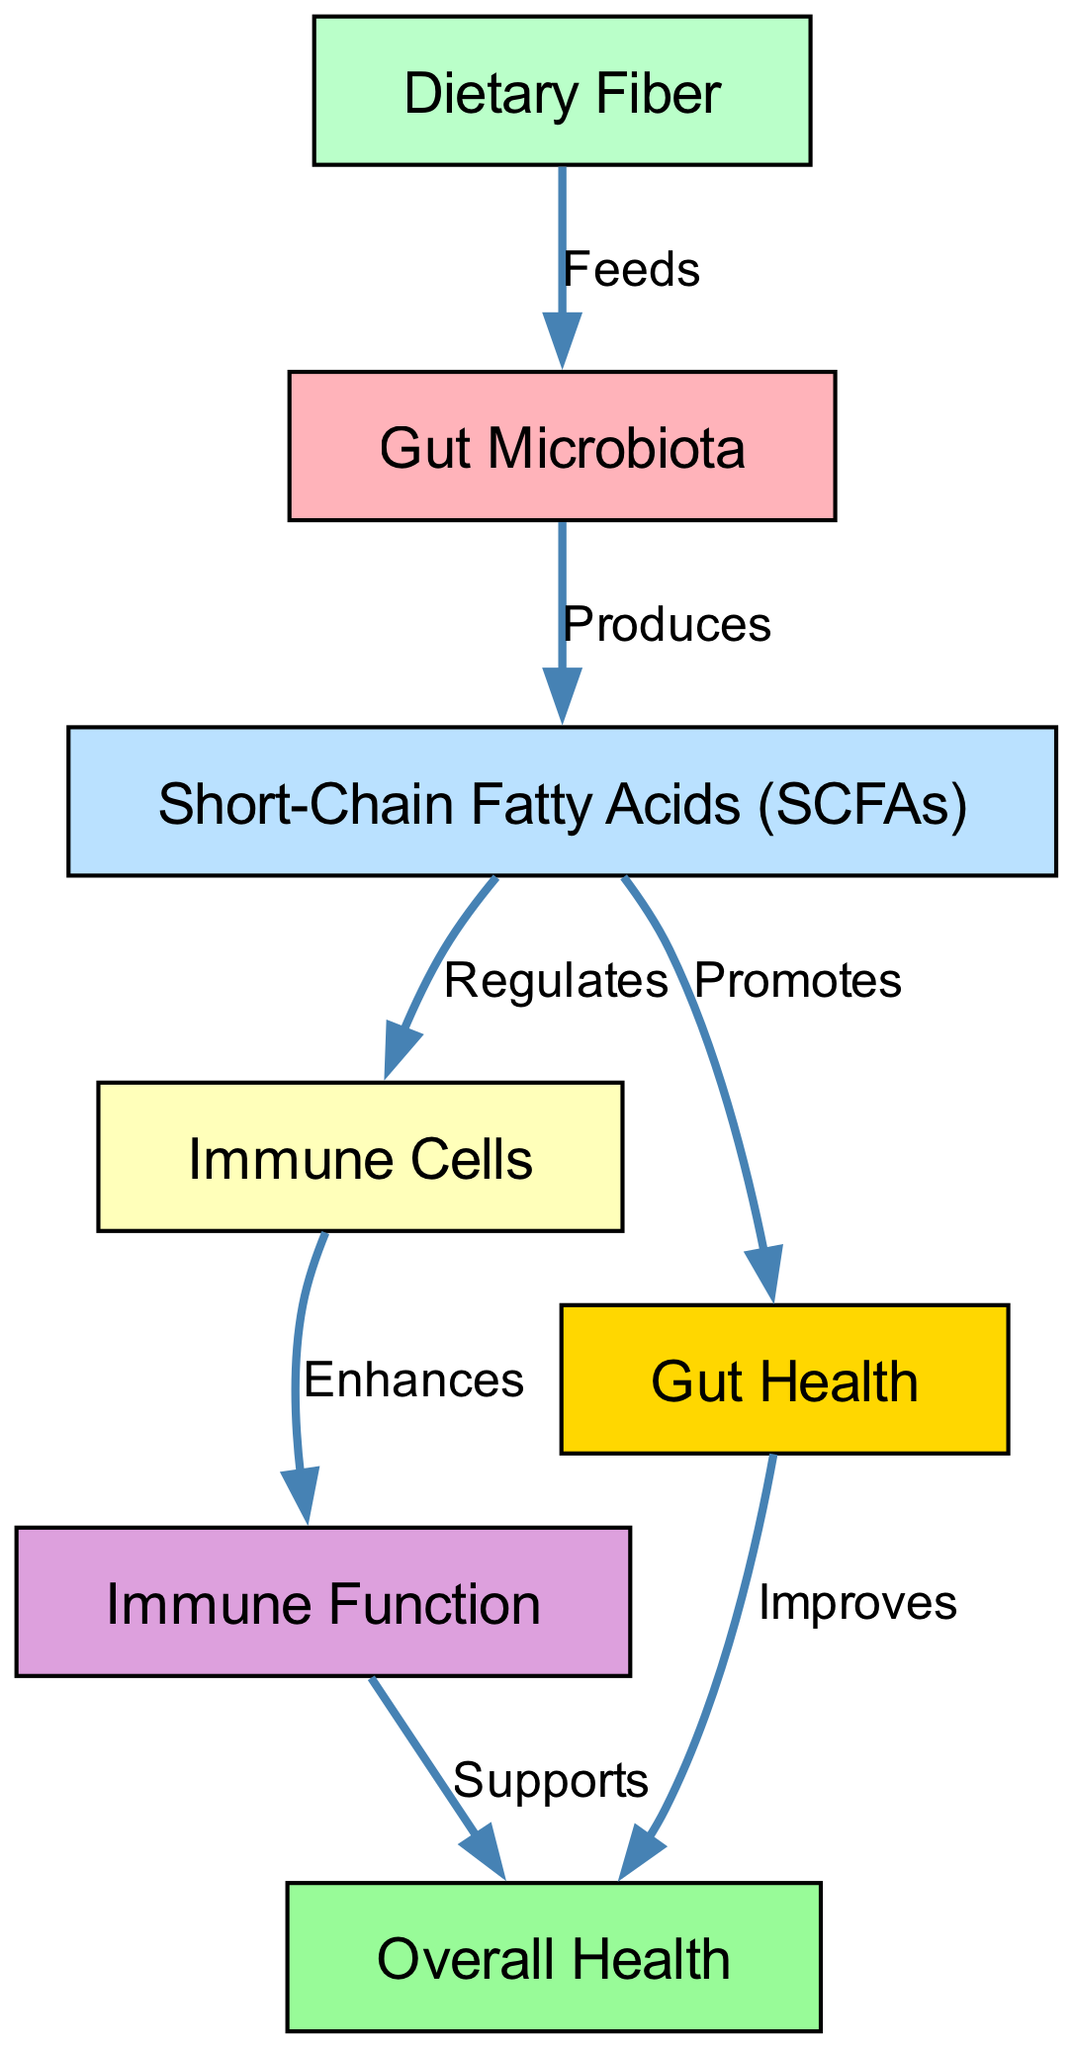What is produced by gut microbiota? The diagram indicates that the gut microbiota produce short-chain fatty acids (SCFAs), as seen in the edge labeled "Produces" between "Gut Microbiota" and "Short-Chain Fatty Acids".
Answer: Short-Chain Fatty Acids (SCFAs) How many nodes are in the diagram? The diagram includes a total of seven nodes, which can be counted as "Gut Microbiota", "Dietary Fiber", "Short-Chain Fatty Acids", "Immune Cells", "Gut Health", "Overall Health", and "Immune Function".
Answer: 7 What does dietary fiber do to gut microbiota? According to the diagram, dietary fiber feeds the gut microbiota, as indicated by the edge labeled "Feeds" between "Dietary Fiber" and "Gut Microbiota".
Answer: Feeds Which node enhances immune function? The edge labeled "Enhances" connects "Immune Cells" to "Immune Function", indicating that immune cells enhance immune function.
Answer: Immune Cells What is the relationship between short-chain fatty acids and gut health? The diagram shows that short-chain fatty acids promote gut health, as seen in the connection labeled "Promotes" between "Short-Chain Fatty Acids" and "Gut Health".
Answer: Promotes What improves overall health? Two pathways improve overall health in the diagram: gut health improves overall health and immune function supports overall health, as indicated by the edges labeled "Improves" and "Supports".
Answer: Gut Health and Immune Function How do short-chain fatty acids affect immune cells? The diagram shows that short-chain fatty acids regulate immune cells, as indicated by the edge labeled "Regulates" transitioning from "Short-Chain Fatty Acids" to "Immune Cells".
Answer: Regulates What is the final outcome of the flow in the diagram? The final outcome is overall health, as indicated by the connections stemming from both "Gut Health" and "Immune Function" leading to "Overall Health".
Answer: Overall Health 